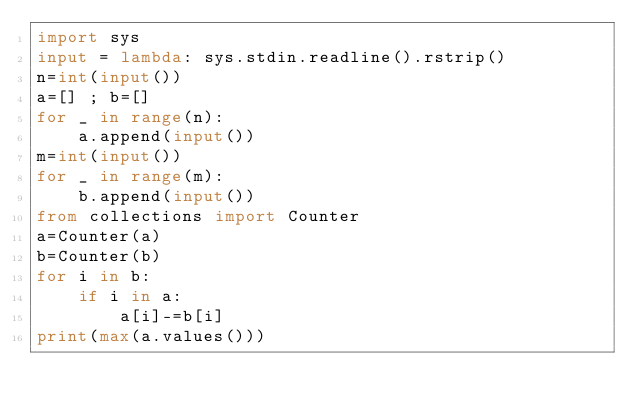Convert code to text. <code><loc_0><loc_0><loc_500><loc_500><_Python_>import sys
input = lambda: sys.stdin.readline().rstrip()
n=int(input())
a=[] ; b=[]
for _ in range(n):
    a.append(input())
m=int(input())
for _ in range(m):
    b.append(input())
from collections import Counter
a=Counter(a)
b=Counter(b)
for i in b:
    if i in a:
        a[i]-=b[i]
print(max(a.values()))
        
</code> 